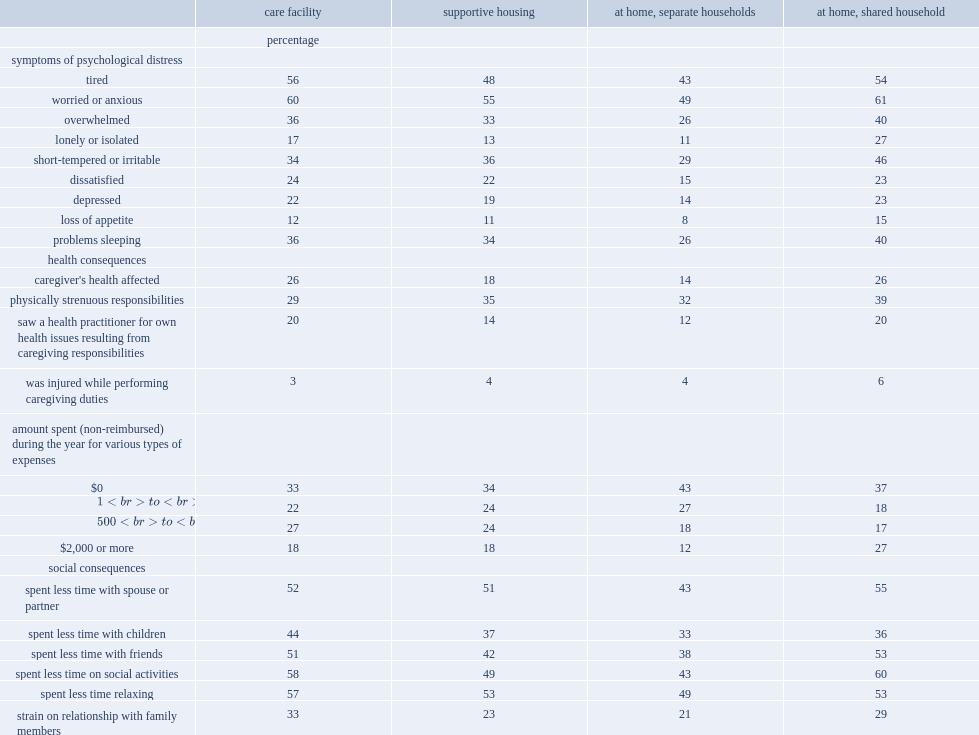How many percent of caregivers of seniors living in a care facility reported feeling depressed as a result of their caregiving responsibilities? 22.0. How many percent of those providing care or help to seniors living in a separate private household? 14.0. Among caregivers of seniors living in a care facility, how many percent stated that their health had been affected by their responsibilities? 26.0. How many percent of caregivers to seniors living in a separate household reported that their responsibilities had affected their health? 14.0. How many percent of caregivers living with their care receiver were more likely than all other caregivers to have spent $2,000 or more on care-related costs? 27.0. 